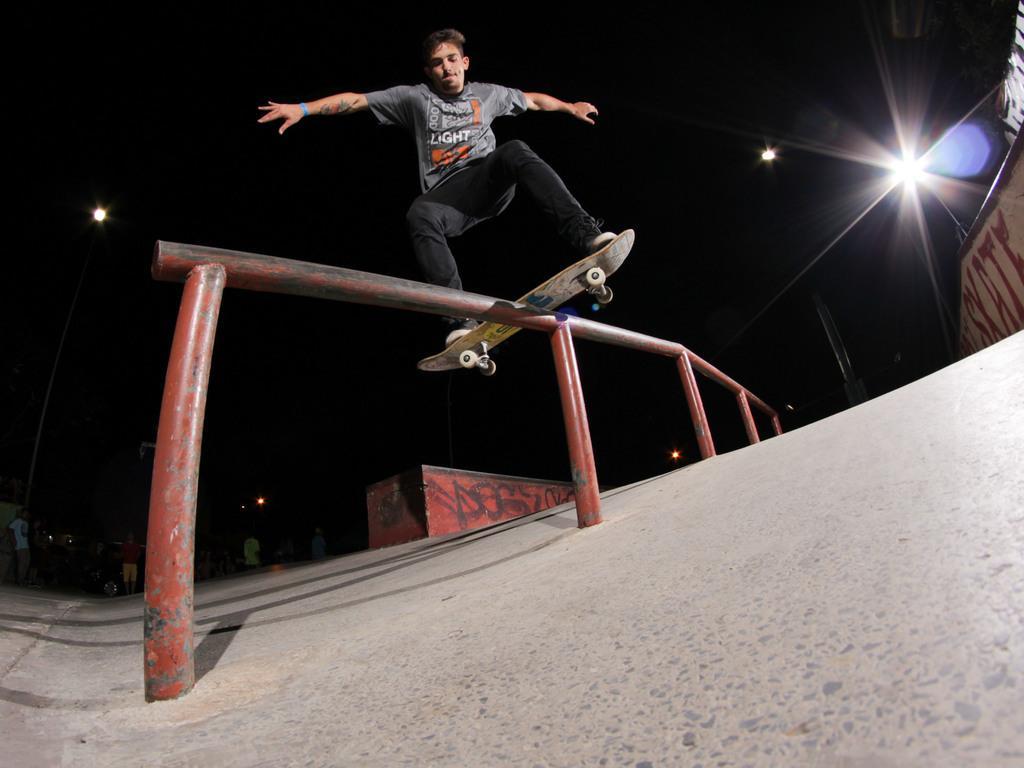In one or two sentences, can you explain what this image depicts? In this image there is a man who is standing on the skateboard. The skateboard is on the pole. At the top there is light. At the bottom there is skating surface. On the right side top there is a wall on which there is some script. 